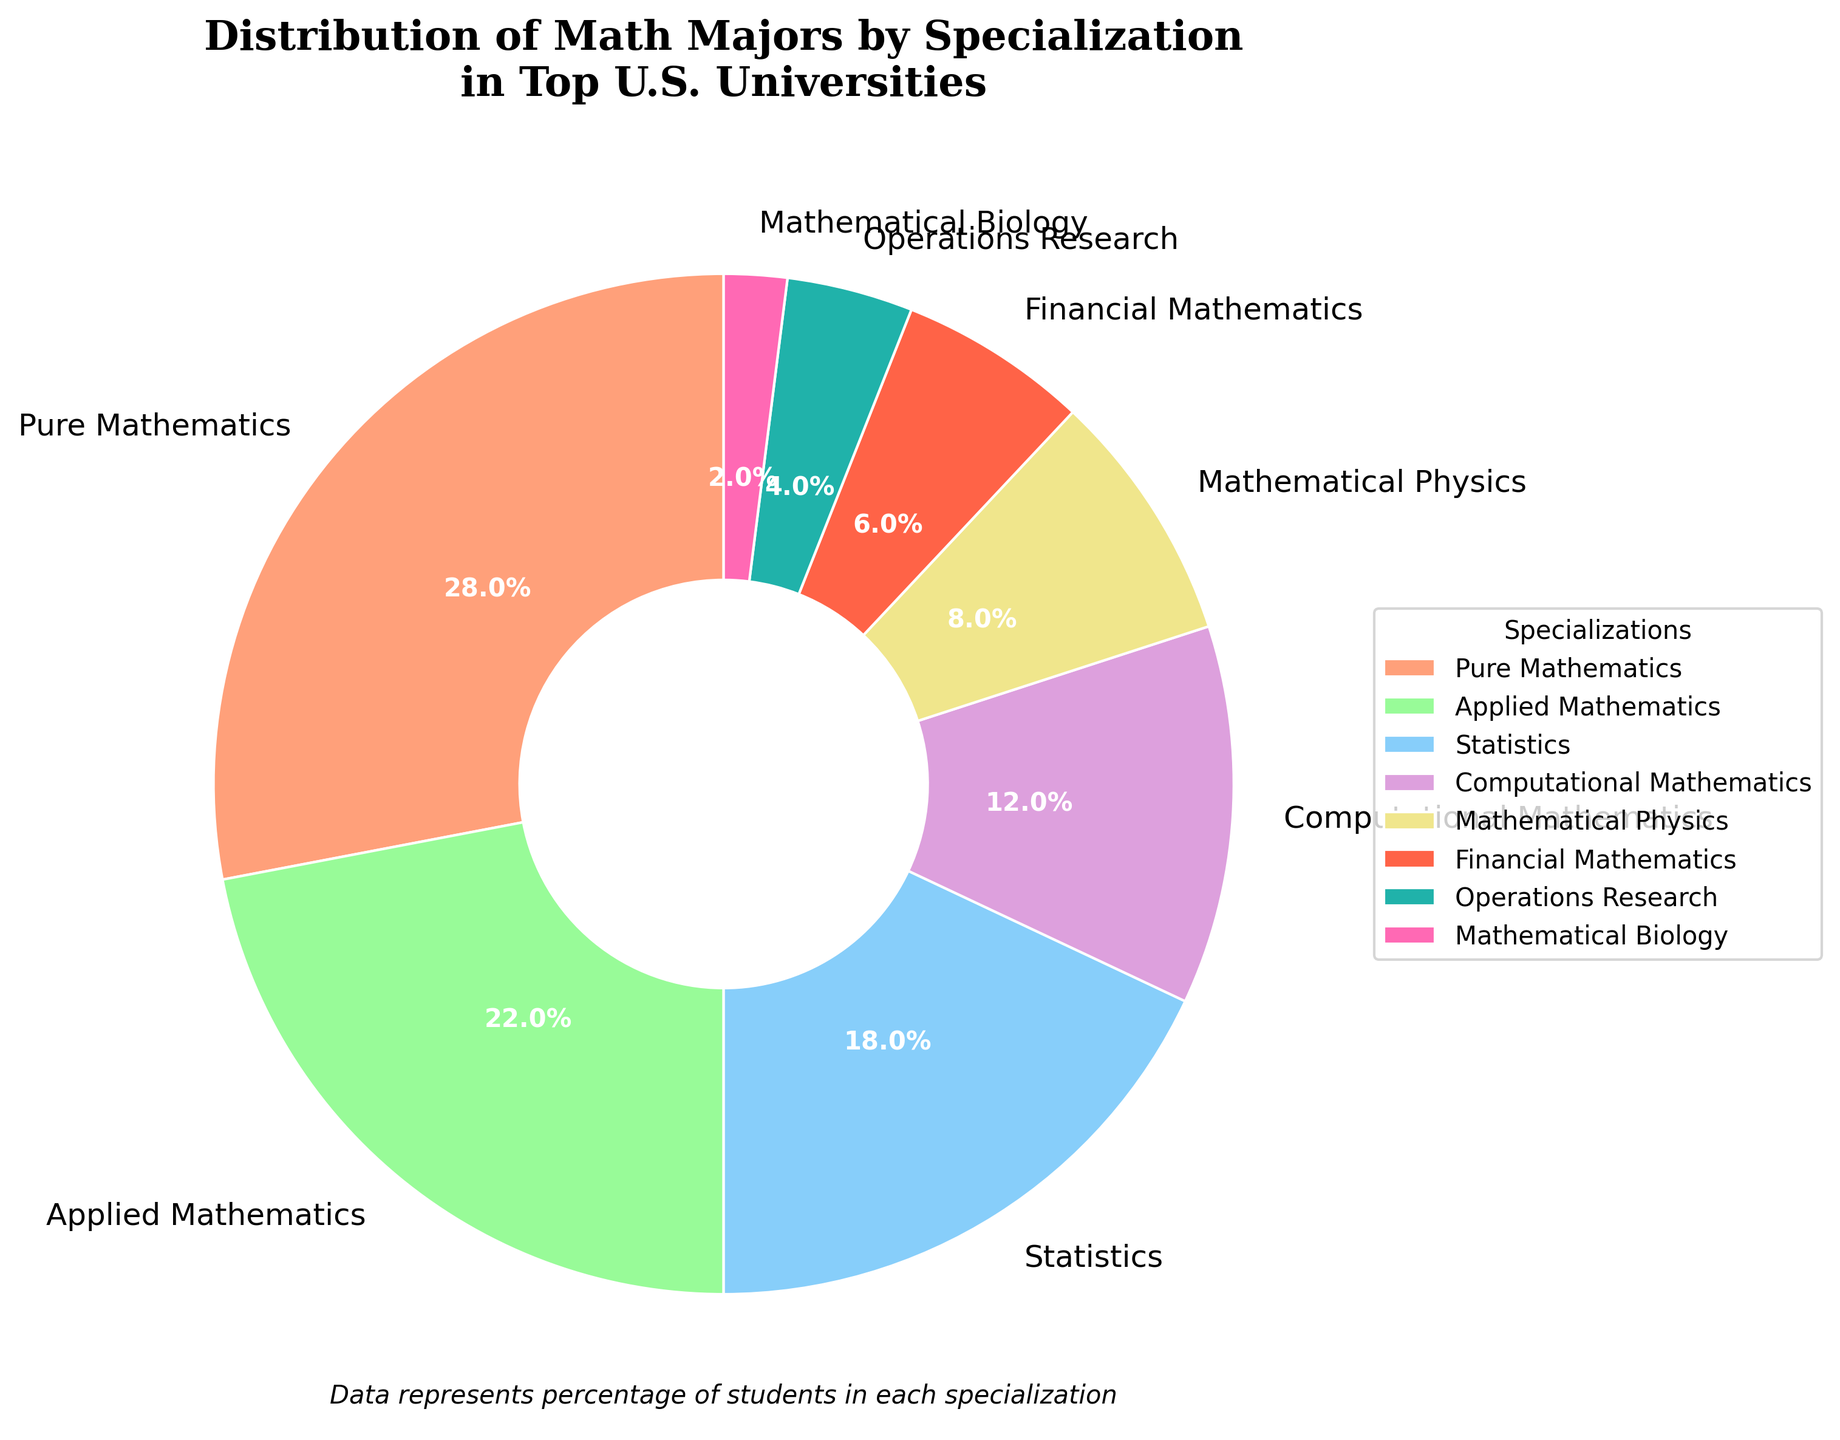What specialization has the highest percentage of math majors? The pie chart shows that Pure Mathematics has the largest portion. By locating the largest slice of the pie chart and reading the label, we see that Pure Mathematics is associated with 28%.
Answer: Pure Mathematics Which specializations have a percentage greater than 20%? By examining the pie chart, any slice larger than one-fifth of the total pie represents a percentage greater than 20%. The slices for Pure Mathematics and Applied Mathematics fit this criterion.
Answer: Pure Mathematics and Applied Mathematics What's the difference in percentage between the largest and smallest specializations? The largest specialization is Pure Mathematics with 28%, and the smallest is Mathematical Biology with 2%. The difference is calculated as 28% - 2% = 26%.
Answer: 26% Which specialization occupies a smaller share of the pie: Financial Mathematics or Operations Research? By comparing the slices and their labeled percentages, Financial Mathematics has 6%, and Operations Research has 4%. Therefore, Operations Research has a smaller share.
Answer: Operations Research What is the total percentage for Computational Mathematics, Mathematical Physics, and Financial Mathematics combined? The slices for Computational Mathematics, Mathematical Physics, and Financial Mathematics are 12%, 8%, and 6% respectively. Adding these together, 12% + 8% + 6% = 26%.
Answer: 26% What range of colors is used for the pie chart? Observing the visual attributes of the pie chart, we see a variety of colors used, including shades like salmon, light green, light blue, purple, light yellow, red, teal, and pink.
Answer: salmon, light green, light blue, purple, light yellow, red, teal, pink What is the combined percentage of all specializations that are below 10%? The specializations and their percentages below 10% are Mathematical Physics (8%), Financial Mathematics (6%), Operations Research (4%), and Mathematical Biology (2%). Summing these values gives 8% + 6% + 4% + 2% = 20%.
Answer: 20% Which specialization has the color closest to light blue? By observing the slices and their respective colors, Computational Mathematics is represented by a light blue shade.
Answer: Computational Mathematics Consider the specializations represented by the smallest three slices. What is their average percentage? The smallest three slices belong to Operations Research (4%), Financial Mathematics (6%), and Mathematical Biology (2%). The average is calculated as (4% + 6% + 2%) / 3 = 12% / 3 = 4%.
Answer: 4% 